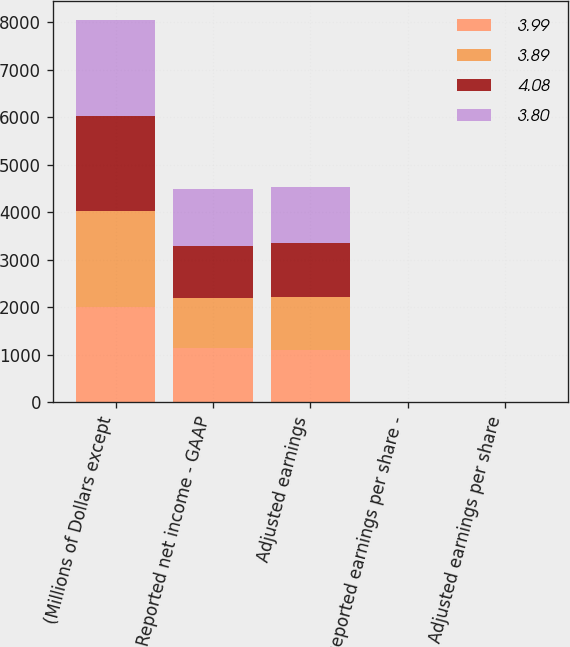Convert chart to OTSL. <chart><loc_0><loc_0><loc_500><loc_500><stacked_bar_chart><ecel><fcel>(Millions of Dollars except<fcel>Reported net income - GAAP<fcel>Adjusted earnings<fcel>Reported earnings per share -<fcel>Adjusted earnings per share<nl><fcel>3.99<fcel>2012<fcel>1138<fcel>1098<fcel>3.88<fcel>3.75<nl><fcel>3.89<fcel>2013<fcel>1062<fcel>1112<fcel>3.62<fcel>3.8<nl><fcel>4.08<fcel>2014<fcel>1092<fcel>1140<fcel>3.73<fcel>3.89<nl><fcel>3.8<fcel>2015<fcel>1193<fcel>1196<fcel>4.07<fcel>4.08<nl></chart> 